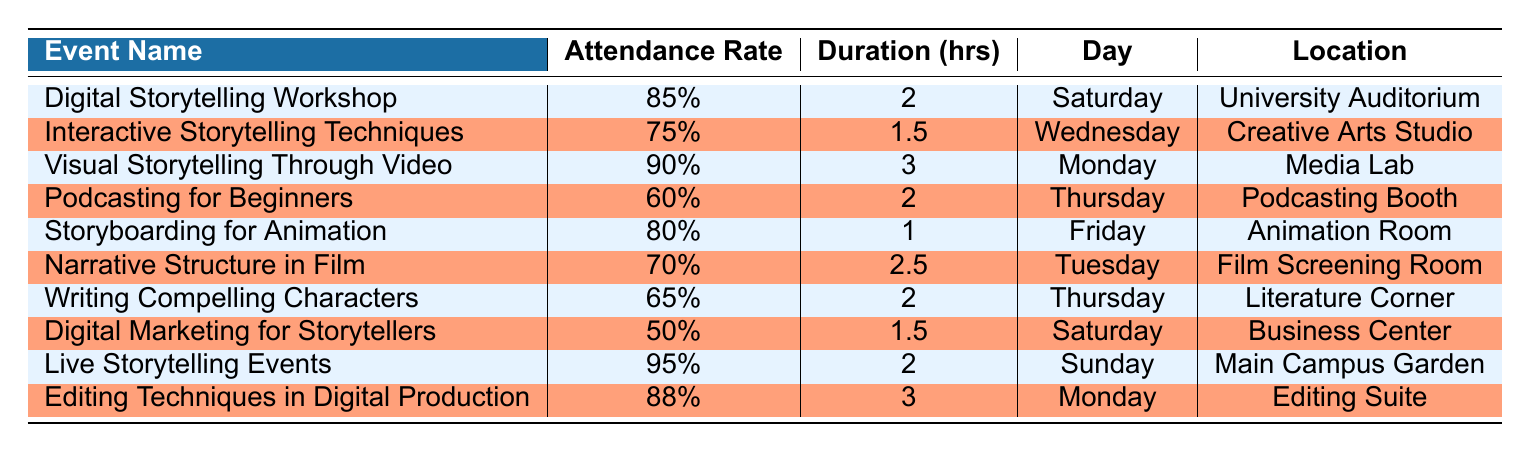What is the attendance rate for the Visual Storytelling Through Video workshop? The attendance rate is listed in the table under the corresponding workshop name "Visual Storytelling Through Video," which shows 90%.
Answer: 90% Which workshop has the longest duration? Checking the "Duration (hrs)" column, I can see that the workshop with the longest duration is "Visual Storytelling Through Video," which lasts for 3 hours.
Answer: Visual Storytelling Through Video What is the average attendance rate of all listed workshops? I sum the attendance rates (85 + 75 + 90 + 60 + 80 + 70 + 65 + 50 + 95 + 88 =  795), and there are 10 workshops. Then, I divide the total attendance rate by the number of workshops (795 / 10 = 79.5).
Answer: 79.5 Is the attendance rate for Digital Marketing for Storytellers higher than 60%? The attendance rate for "Digital Marketing for Storytellers" is 50%, which is lower than 60%. So the answer is no.
Answer: No On which day is the Podcasting for Beginners workshop scheduled? The corresponding workshop "Podcasting for Beginners" is scheduled on Thursday, according to the "Day" column in the table.
Answer: Thursday Which two workshops have attendance rates below 70%? By reviewing the "Attendance Rate" column, I find that "Podcasting for Beginners" (60%) and "Digital Marketing for Storytellers" (50%) are the only two workshops below 70%.
Answer: Podcasting for Beginners and Digital Marketing for Storytellers What is the total duration of all workshops scheduled on Saturday? I check the "Duration (hrs)" column for workshops scheduled on Saturday: "Digital Storytelling Workshop" (2 hours) and "Digital Marketing for Storytellers" (1.5 hours). The total is (2 + 1.5 = 3.5 hours).
Answer: 3.5 hours Is the attendance rate for Live Storytelling Events the highest among all workshops? The attendance rate for "Live Storytelling Events" is 95%, which is higher than all other workshop attendance rates listed in the table. Thus, yes, it is the highest.
Answer: Yes How many workshops have a duration greater than 2 hours? I look at the "Duration (hrs)" column and find that "Visual Storytelling Through Video" (3 hours), "Editing Techniques in Digital Production" (3 hours), and "Narrative Structure in Film" (2.5 hours) all have a duration greater than 2 hours. That counts as three workshops.
Answer: 3 